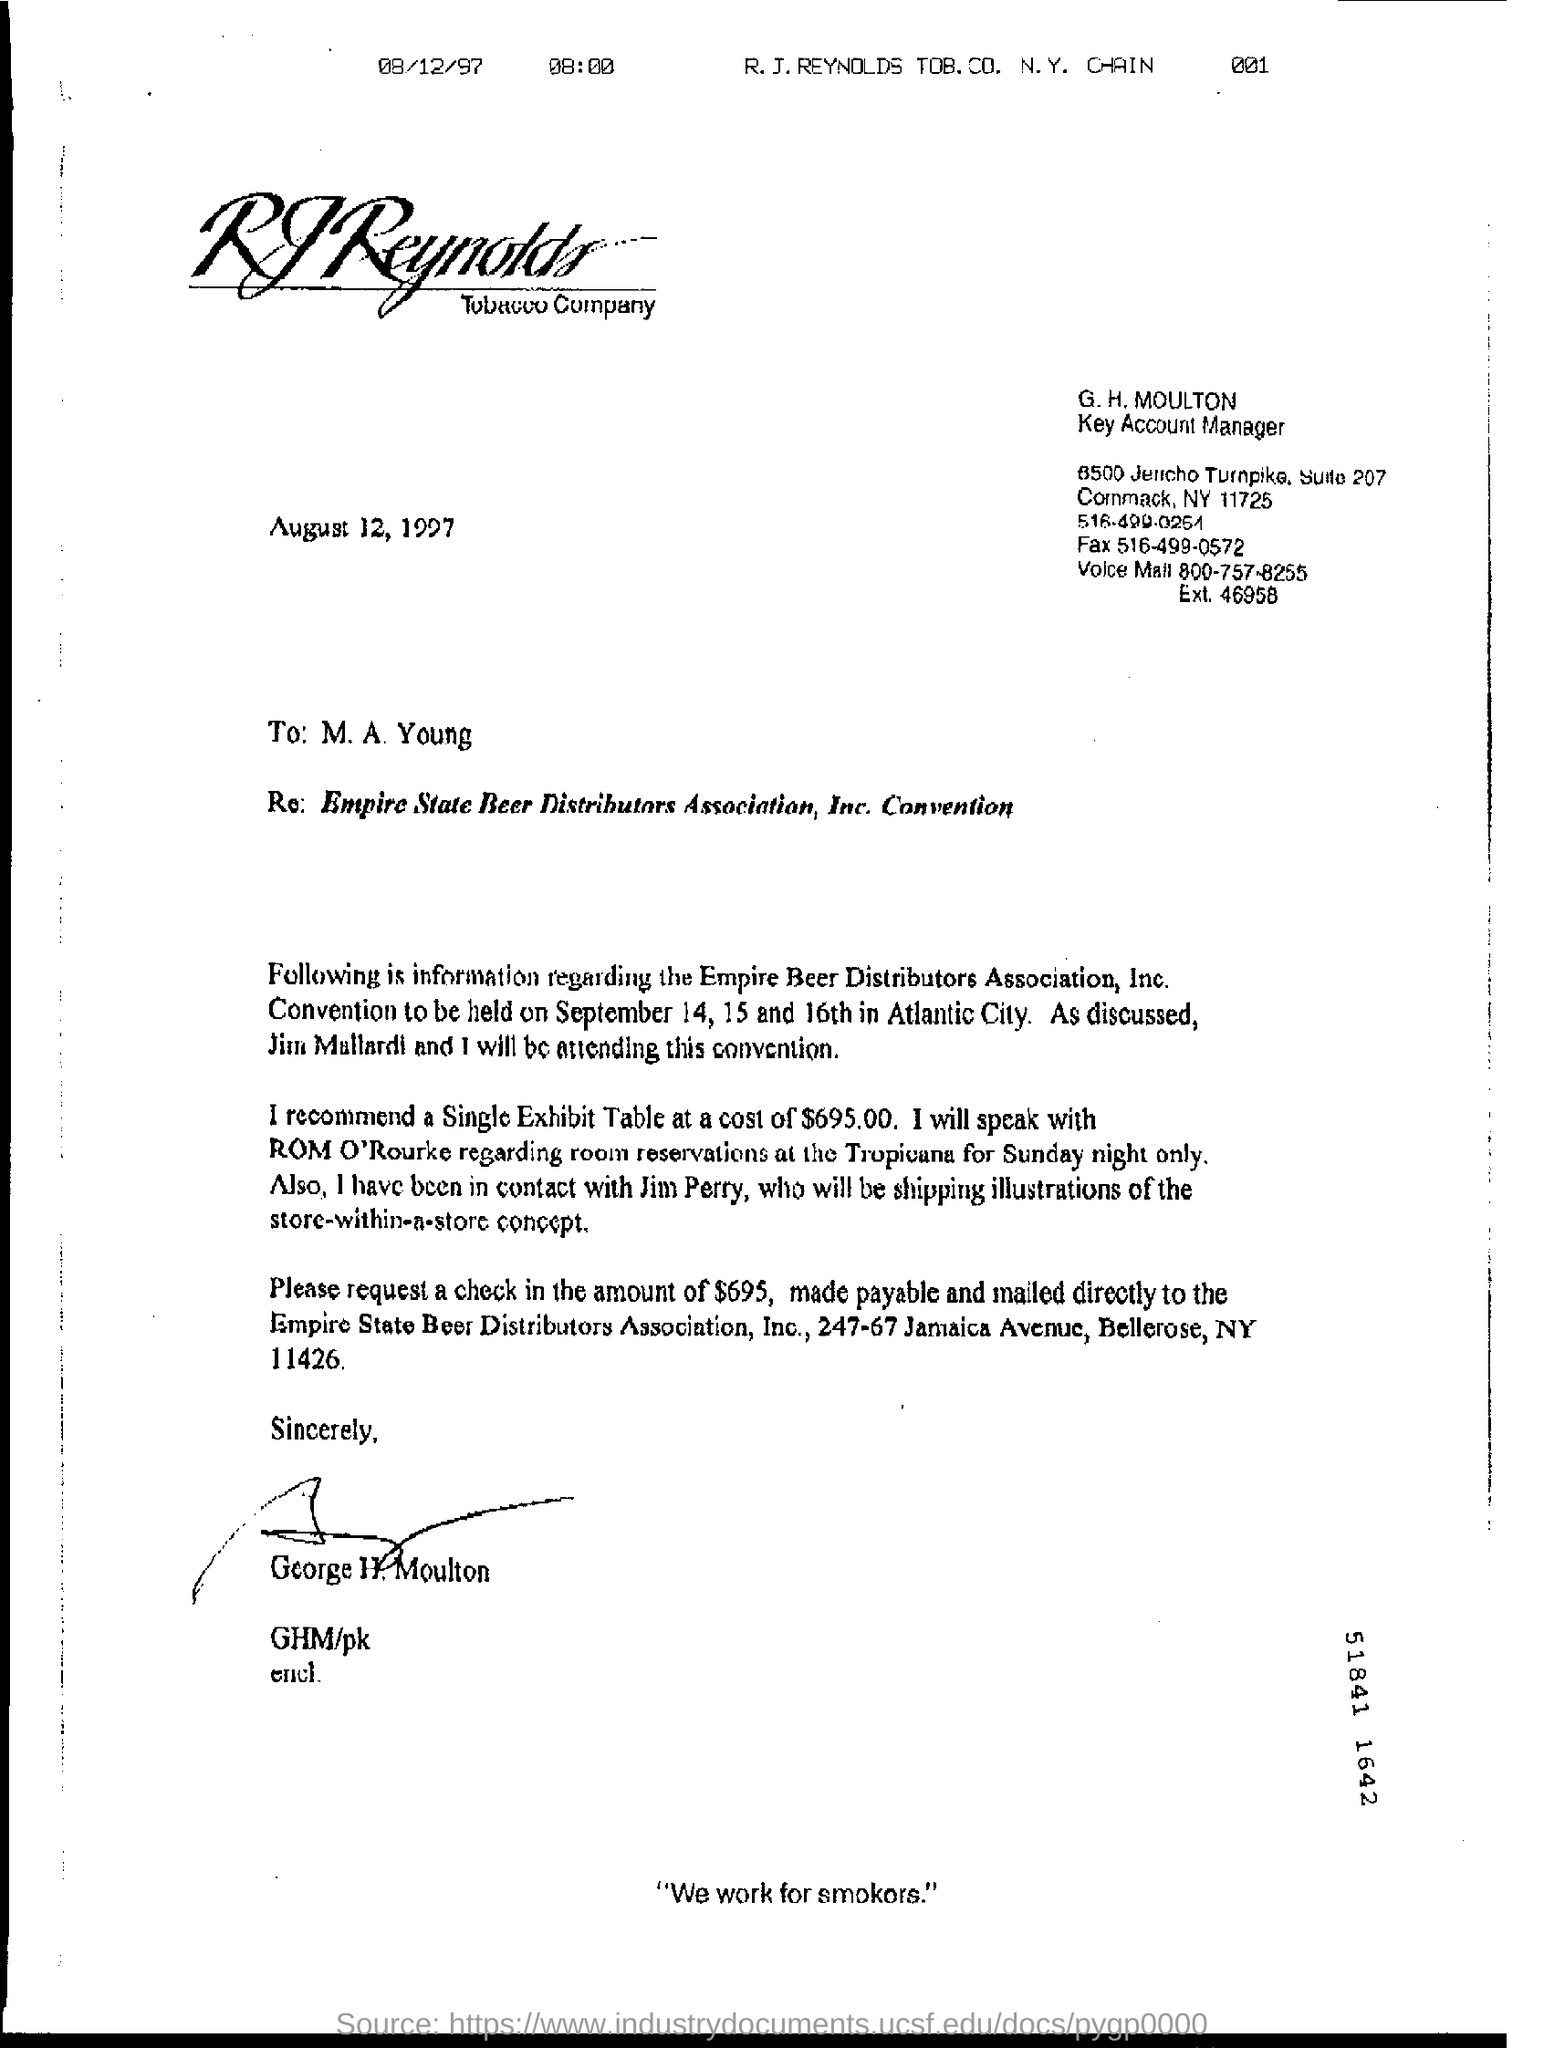What is G.H. Moulton's designation?
Ensure brevity in your answer.  Key account manager. When is the Empire Beer Distributors Association, Inc. Convention going to be held?
Offer a terse response. September 14, 15 and 16th. Where is the Convention going to be held?
Keep it short and to the point. Atlantic City. How much will a Single Exhibit Table cost?
Offer a terse response. $695.00. 